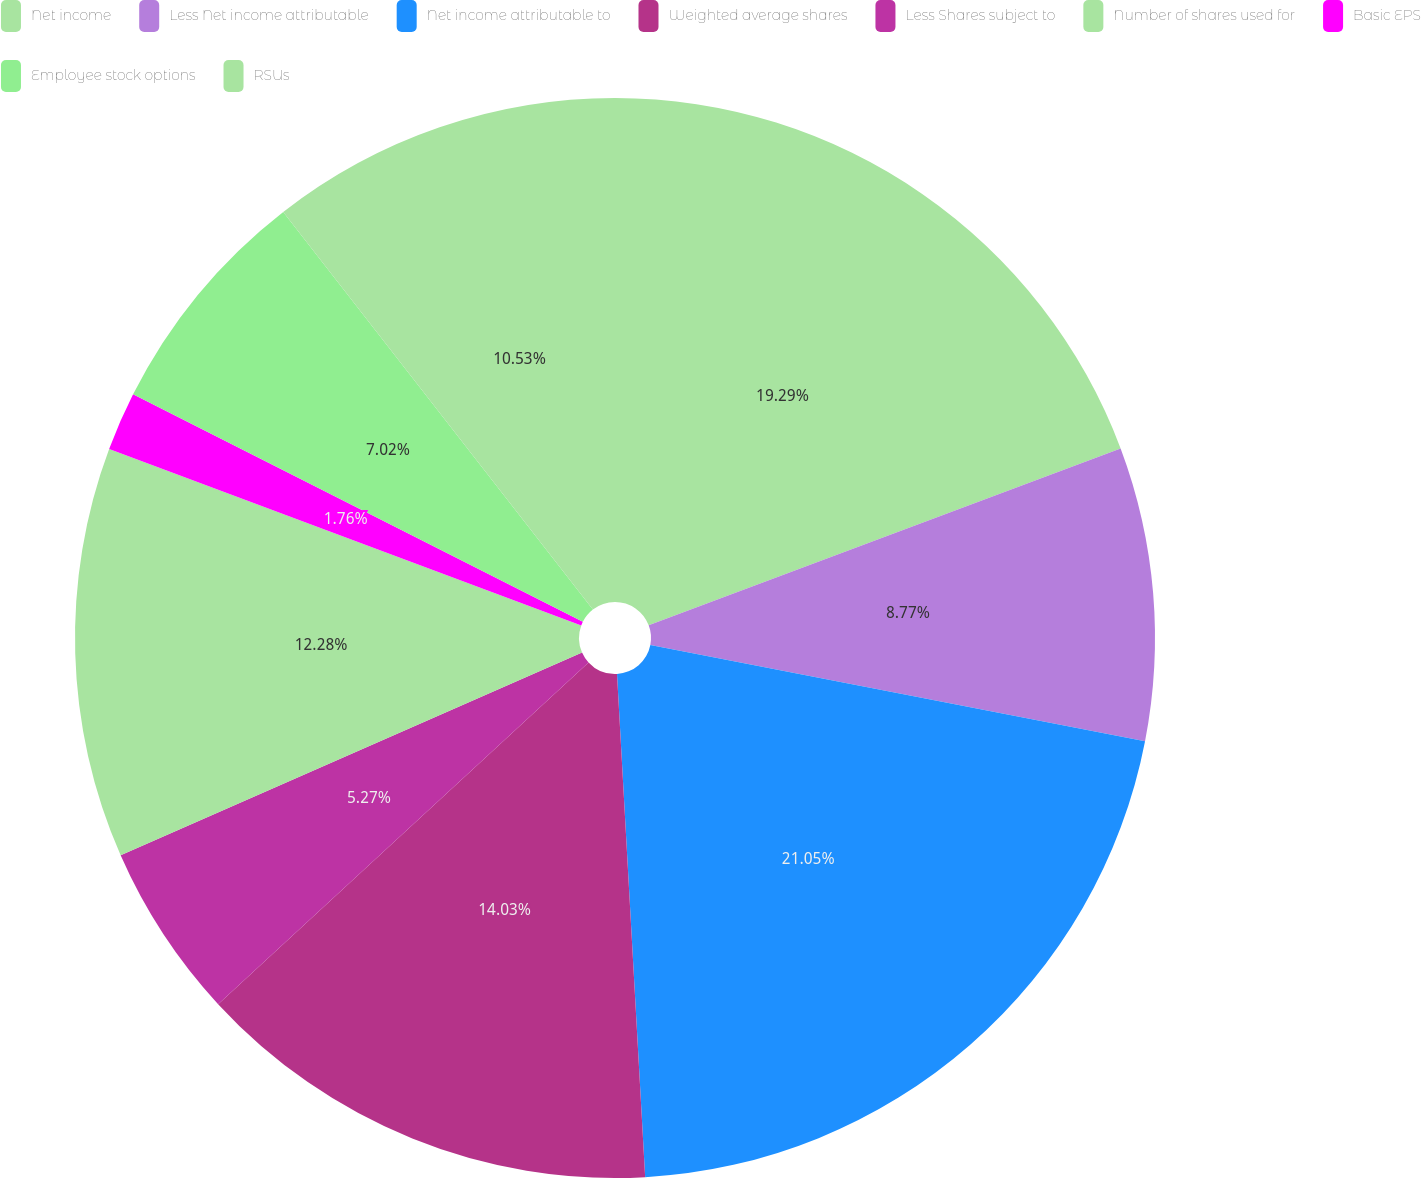Convert chart. <chart><loc_0><loc_0><loc_500><loc_500><pie_chart><fcel>Net income<fcel>Less Net income attributable<fcel>Net income attributable to<fcel>Weighted average shares<fcel>Less Shares subject to<fcel>Number of shares used for<fcel>Basic EPS<fcel>Employee stock options<fcel>RSUs<nl><fcel>19.29%<fcel>8.77%<fcel>21.05%<fcel>14.03%<fcel>5.27%<fcel>12.28%<fcel>1.76%<fcel>7.02%<fcel>10.53%<nl></chart> 